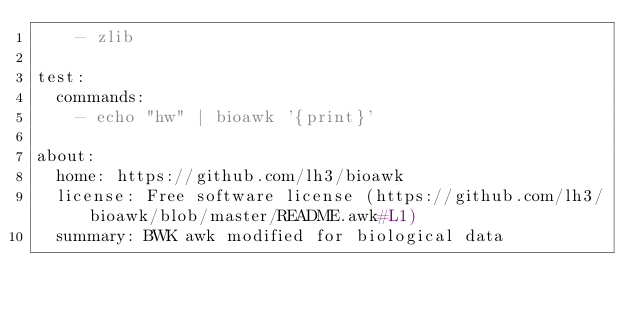<code> <loc_0><loc_0><loc_500><loc_500><_YAML_>    - zlib

test:
  commands:
    - echo "hw" | bioawk '{print}'

about:
  home: https://github.com/lh3/bioawk
  license: Free software license (https://github.com/lh3/bioawk/blob/master/README.awk#L1)
  summary: BWK awk modified for biological data
</code> 